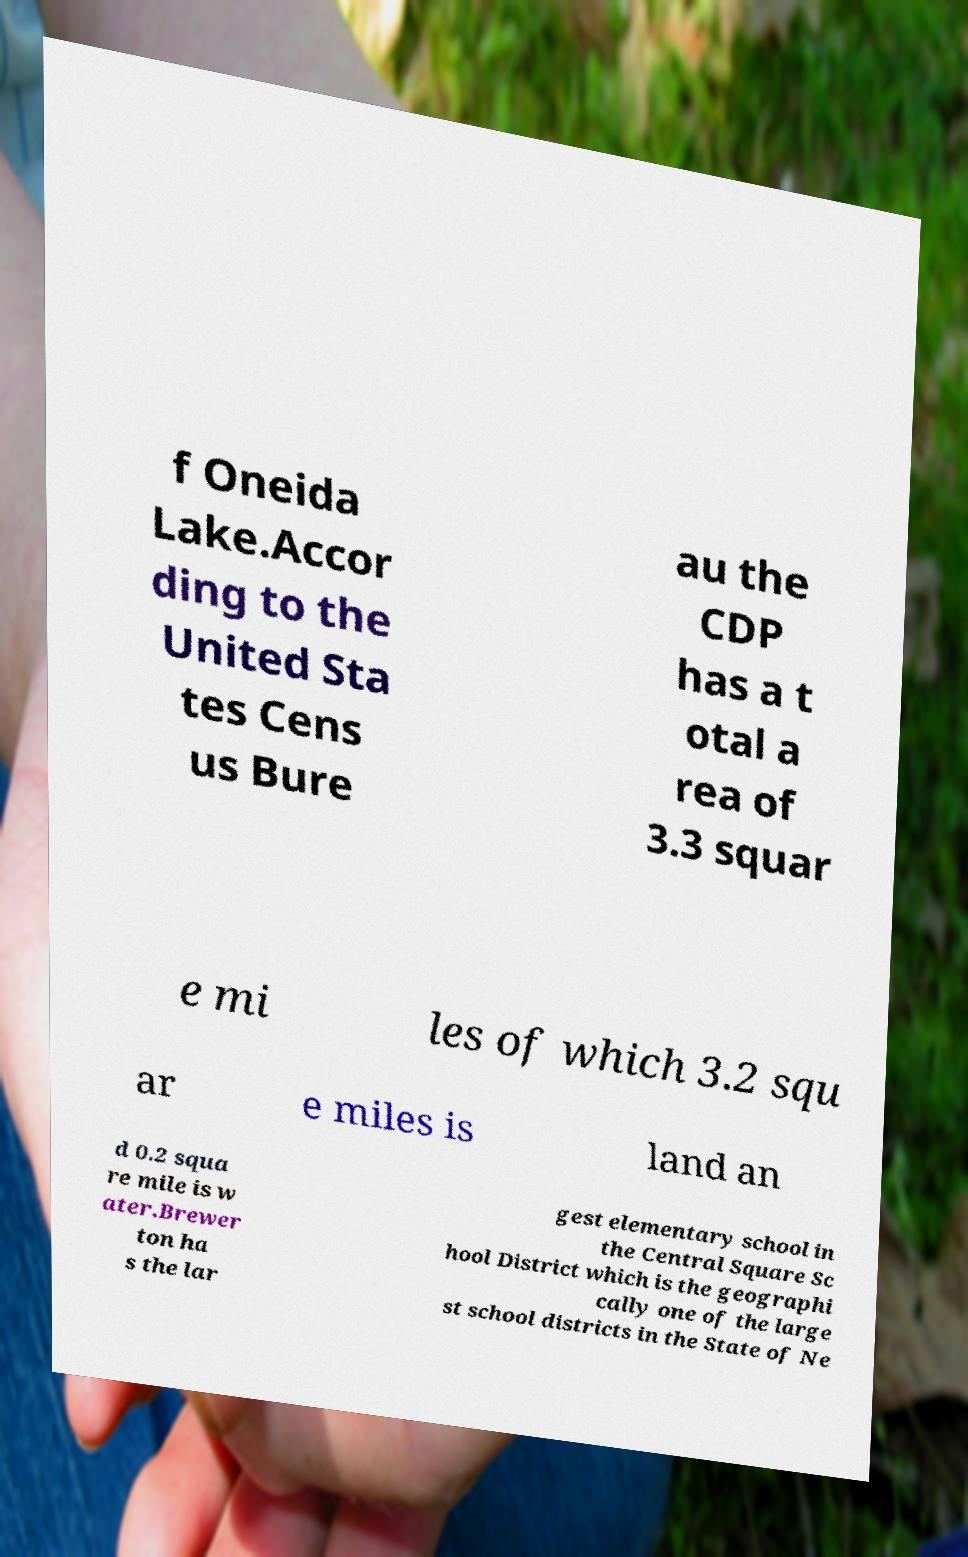There's text embedded in this image that I need extracted. Can you transcribe it verbatim? f Oneida Lake.Accor ding to the United Sta tes Cens us Bure au the CDP has a t otal a rea of 3.3 squar e mi les of which 3.2 squ ar e miles is land an d 0.2 squa re mile is w ater.Brewer ton ha s the lar gest elementary school in the Central Square Sc hool District which is the geographi cally one of the large st school districts in the State of Ne 